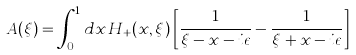Convert formula to latex. <formula><loc_0><loc_0><loc_500><loc_500>A ( \xi ) = \int _ { 0 } ^ { 1 } d x \, H _ { + } ( x , \xi ) \left [ \frac { 1 } { \xi - x - i \epsilon } - \frac { 1 } { \xi + x - i \epsilon } \right ]</formula> 